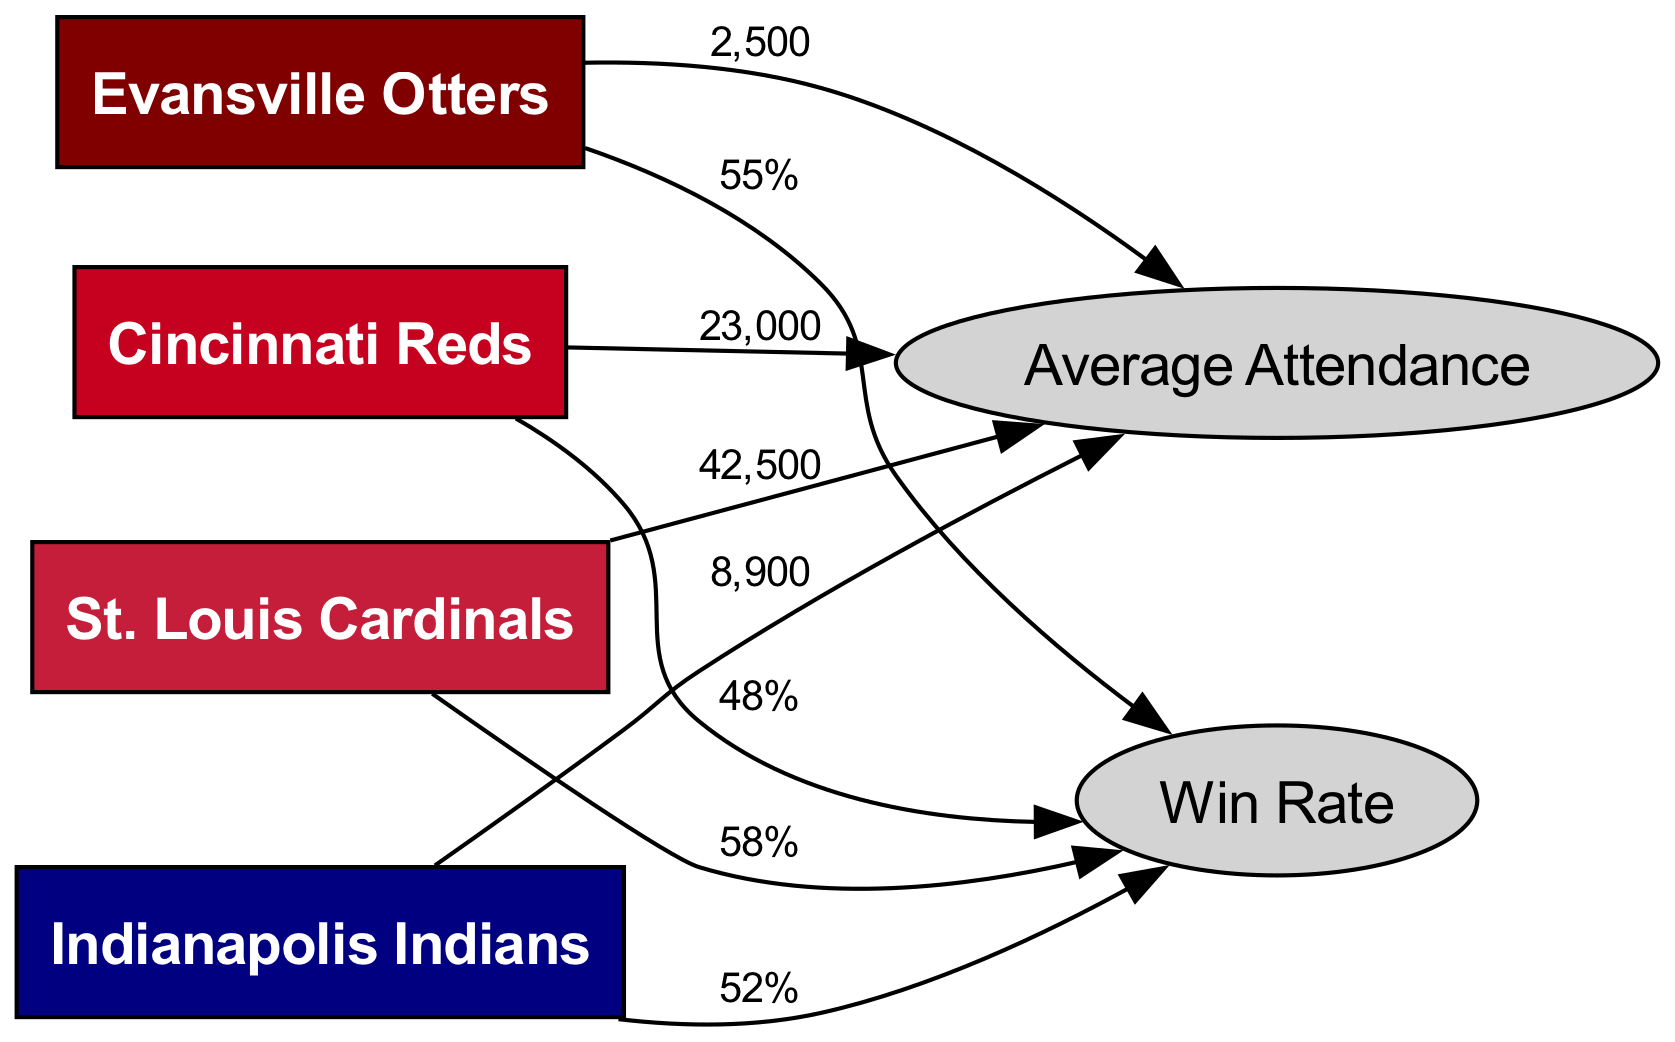What is the average attendance of the Evansville Otters? The diagram shows a direct connection from the Evansville Otters to the average attendance node with the label '2,500', indicating that the average attendance for the Otters is 2,500.
Answer: 2,500 What is the win rate of the St. Louis Cardinals? The diagram indicates that the St. Louis Cardinals are linked to the win rate node with the label '58%', which specifies that their win rate is 58%.
Answer: 58% Which team has the highest average attendance? By comparing the average attendance values connected to each team, St. Louis Cardinals have the highest attendance of 42,500, which is more than any other team in the diagram.
Answer: St. Louis Cardinals What is the win rate of the team with the lowest average attendance? The Evansville Otters have the lowest average attendance at 2,500, and their win rate node shows a label of '55%', thus their win rate is 55%.
Answer: 55% How many teams are represented in the diagram? The diagram shows a total of four teams with nodes for the Evansville Otters, Indianapolis Indians, St. Louis Cardinals, and Cincinnati Reds, indicating there are 4 teams.
Answer: 4 Which city has a lower win rate, Cincinnati or Indianapolis? By inspecting the win rate labels, Cincinnati Reds have a win rate of 48% and Indianapolis Indians have a win rate of 52%. Since 48% is less than 52%, Cincinnati has the lower win rate.
Answer: Cincinnati Reds What is the average attendance of the Indianapolis Indians? The attendance node connected to the Indianapolis Indians shows the label '8,900', indicating that their average attendance is 8,900.
Answer: 8,900 Which team has the lowest win rate among the teams listed? The Cincinnati Reds have the lowest win rate as indicated by the label '48%', which is the smallest value in the win rate connections compared to the other teams.
Answer: Cincinnati Reds What is the average attendance of the Cincinnati Reds? The diagram reveals that the Cincinnati Reds are connected to the average attendance node with a label of '23,000', indicating their average attendance is 23,000.
Answer: 23,000 